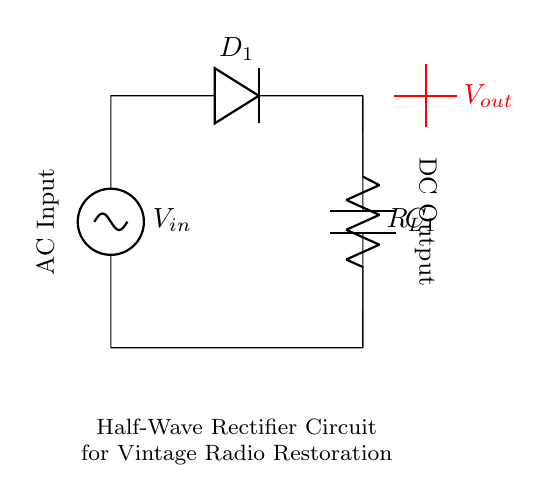What is the type of rectifier shown in the circuit? The circuit diagram shows a half-wave rectifier, as indicated by the single diode configuration that only allows current to pass in one direction.
Answer: half-wave rectifier How many diodes are used in this circuit? The circuit features one diode, which is responsible for rectifying the alternating current by allowing flow in only one direction.
Answer: one What is the purpose of the capacitor in the circuit? The capacitor is used to smooth the output voltage by filtering the rectified output, reducing voltage fluctuations and providing a more stable DC voltage.
Answer: smooth output What is the configuration of the load resistor in the circuit? The load resistor is connected in series with the diode, allowing it to receive the rectified voltage for powering the radio circuit.
Answer: series What is the input voltage type for this rectifier circuit? The input voltage is alternating current (AC), which is necessary for the function of the rectifier that converts it into direct current (DC).
Answer: alternating current How does the current flow during the conduction phase of the diode? During the conduction phase, the current flows from the input voltage source through the diode, then through the load resistor, completing the circuit back to the source.
Answer: from input to load What can be inferred about the relationship between the input and output waveforms? The output waveform will be a series of positive half cycles, with the negative half cycles blocked by the diode, resulting in a pulsating DC voltage.
Answer: positive half cycles 